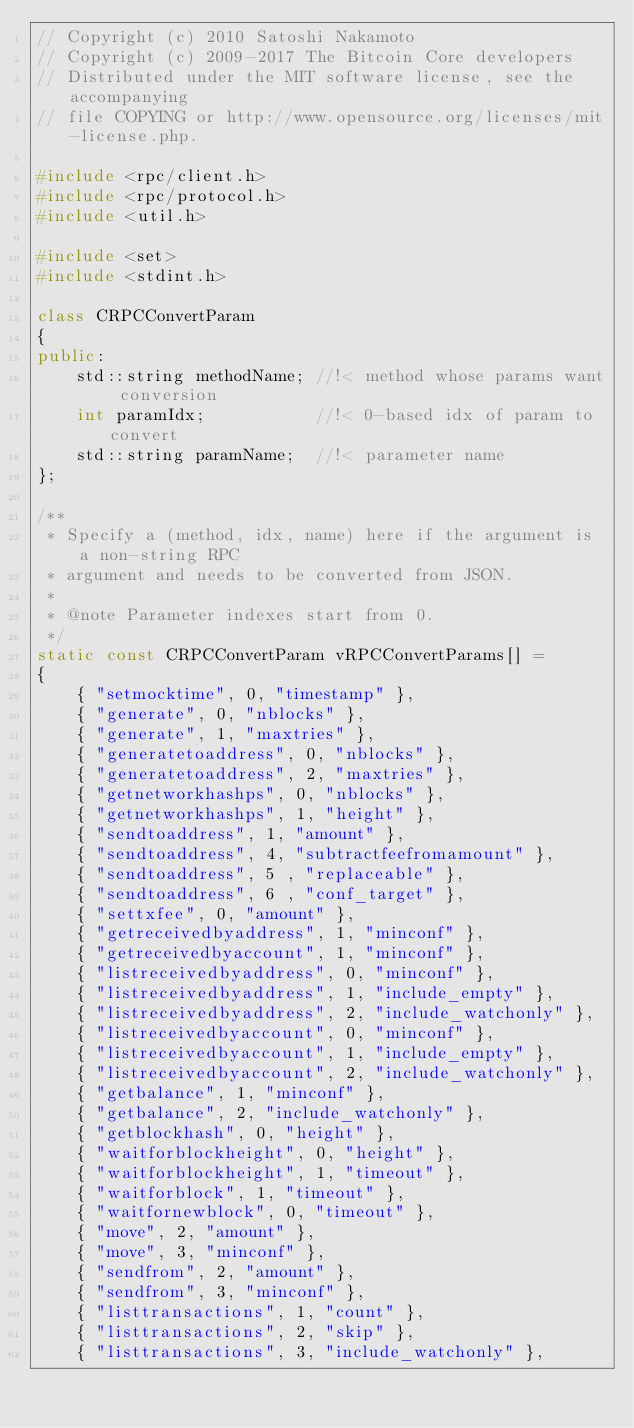<code> <loc_0><loc_0><loc_500><loc_500><_C++_>// Copyright (c) 2010 Satoshi Nakamoto
// Copyright (c) 2009-2017 The Bitcoin Core developers
// Distributed under the MIT software license, see the accompanying
// file COPYING or http://www.opensource.org/licenses/mit-license.php.

#include <rpc/client.h>
#include <rpc/protocol.h>
#include <util.h>

#include <set>
#include <stdint.h>

class CRPCConvertParam
{
public:
    std::string methodName; //!< method whose params want conversion
    int paramIdx;           //!< 0-based idx of param to convert
    std::string paramName;  //!< parameter name
};

/**
 * Specify a (method, idx, name) here if the argument is a non-string RPC
 * argument and needs to be converted from JSON.
 *
 * @note Parameter indexes start from 0.
 */
static const CRPCConvertParam vRPCConvertParams[] =
{
    { "setmocktime", 0, "timestamp" },
    { "generate", 0, "nblocks" },
    { "generate", 1, "maxtries" },
    { "generatetoaddress", 0, "nblocks" },
    { "generatetoaddress", 2, "maxtries" },
    { "getnetworkhashps", 0, "nblocks" },
    { "getnetworkhashps", 1, "height" },
    { "sendtoaddress", 1, "amount" },
    { "sendtoaddress", 4, "subtractfeefromamount" },
    { "sendtoaddress", 5 , "replaceable" },
    { "sendtoaddress", 6 , "conf_target" },
    { "settxfee", 0, "amount" },
    { "getreceivedbyaddress", 1, "minconf" },
    { "getreceivedbyaccount", 1, "minconf" },
    { "listreceivedbyaddress", 0, "minconf" },
    { "listreceivedbyaddress", 1, "include_empty" },
    { "listreceivedbyaddress", 2, "include_watchonly" },
    { "listreceivedbyaccount", 0, "minconf" },
    { "listreceivedbyaccount", 1, "include_empty" },
    { "listreceivedbyaccount", 2, "include_watchonly" },
    { "getbalance", 1, "minconf" },
    { "getbalance", 2, "include_watchonly" },
    { "getblockhash", 0, "height" },
    { "waitforblockheight", 0, "height" },
    { "waitforblockheight", 1, "timeout" },
    { "waitforblock", 1, "timeout" },
    { "waitfornewblock", 0, "timeout" },
    { "move", 2, "amount" },
    { "move", 3, "minconf" },
    { "sendfrom", 2, "amount" },
    { "sendfrom", 3, "minconf" },
    { "listtransactions", 1, "count" },
    { "listtransactions", 2, "skip" },
    { "listtransactions", 3, "include_watchonly" },</code> 